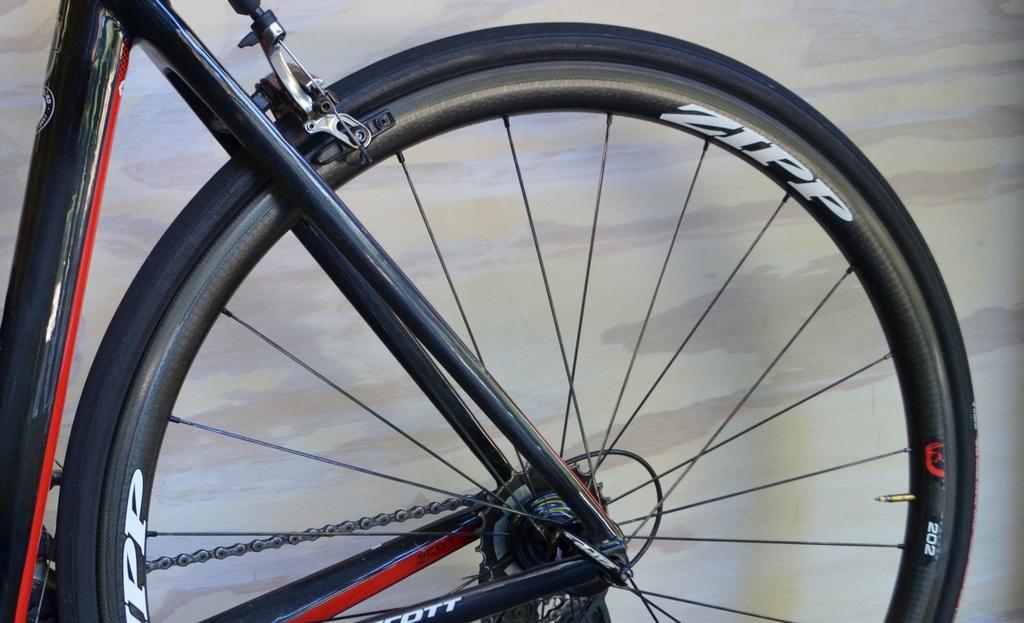In one or two sentences, can you explain what this image depicts? In the image we can see a bicycle wheel. Behind the bicycle we can see a wall. 